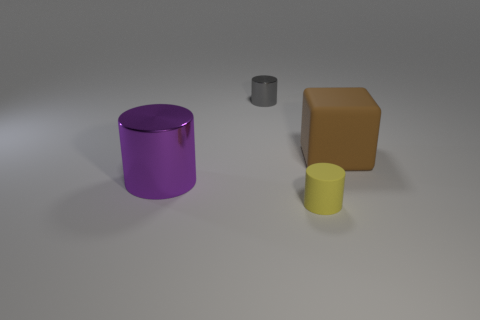Subtract all small yellow cylinders. How many cylinders are left? 2 Subtract all cylinders. How many objects are left? 1 Add 4 blue balls. How many objects exist? 8 Subtract all yellow cylinders. How many cylinders are left? 2 Subtract all yellow cylinders. Subtract all brown balls. How many cylinders are left? 2 Subtract all big purple cylinders. Subtract all purple cylinders. How many objects are left? 2 Add 1 things. How many things are left? 5 Add 4 yellow rubber things. How many yellow rubber things exist? 5 Subtract 0 purple cubes. How many objects are left? 4 Subtract 1 blocks. How many blocks are left? 0 